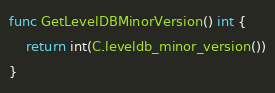Convert code to text. <code><loc_0><loc_0><loc_500><loc_500><_Go_>func GetLevelDBMinorVersion() int {
	return int(C.leveldb_minor_version())
}
</code> 